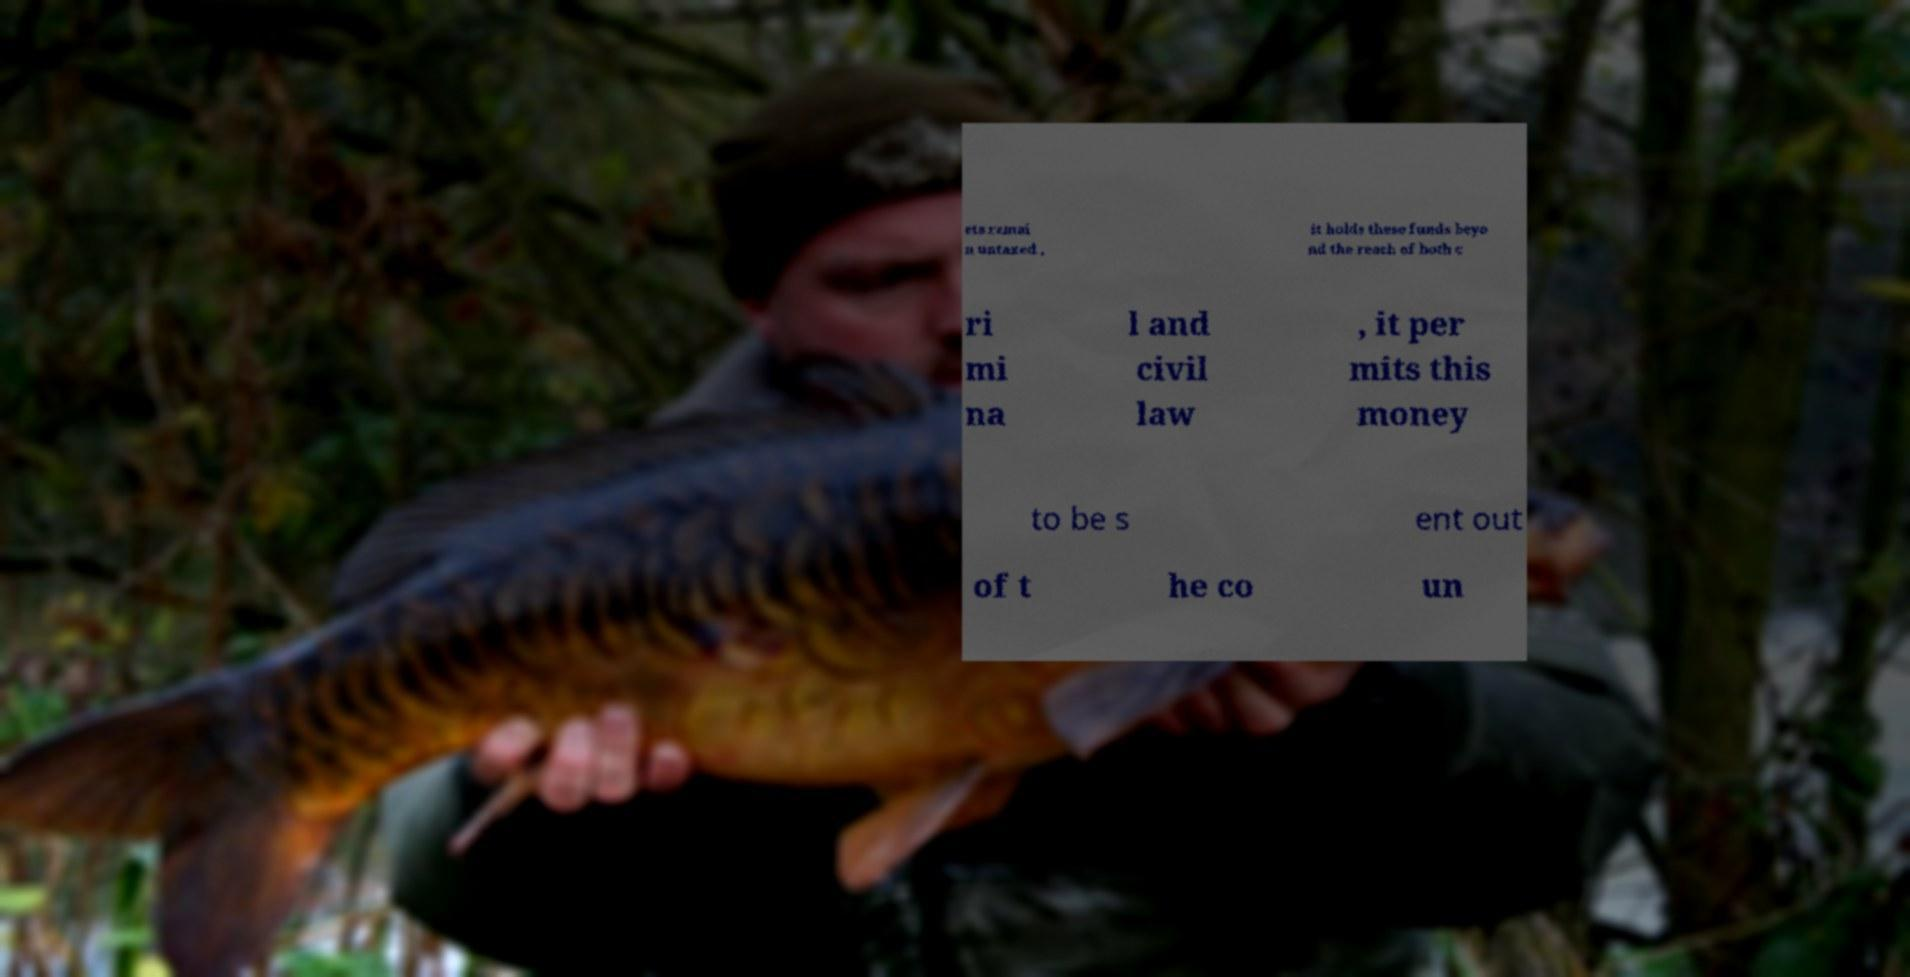For documentation purposes, I need the text within this image transcribed. Could you provide that? ets remai n untaxed , it holds these funds beyo nd the reach of both c ri mi na l and civil law , it per mits this money to be s ent out of t he co un 